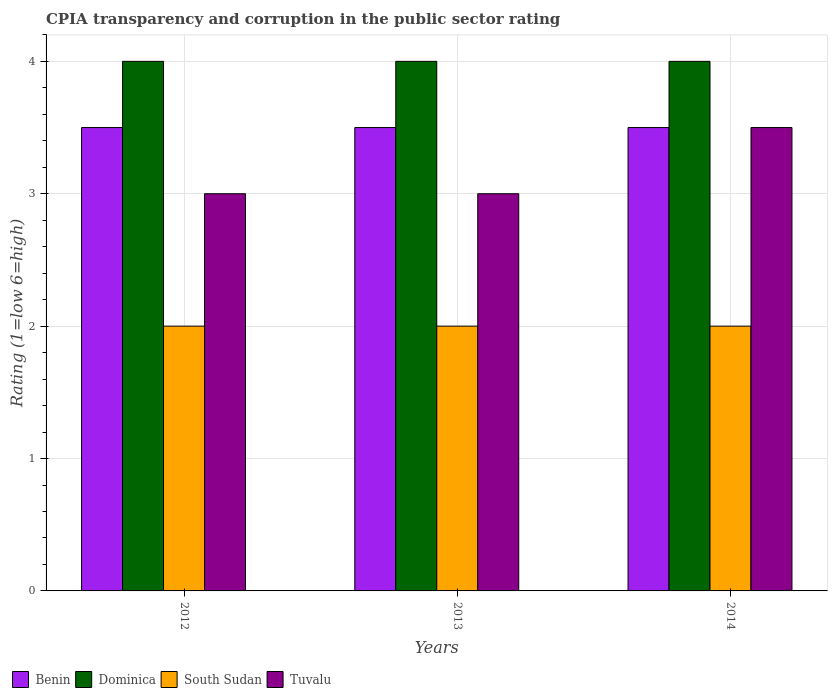How many different coloured bars are there?
Provide a short and direct response. 4. How many bars are there on the 1st tick from the left?
Your answer should be compact. 4. How many bars are there on the 3rd tick from the right?
Give a very brief answer. 4. In how many cases, is the number of bars for a given year not equal to the number of legend labels?
Keep it short and to the point. 0. In which year was the CPIA rating in Dominica minimum?
Offer a very short reply. 2012. In the year 2012, what is the difference between the CPIA rating in Tuvalu and CPIA rating in South Sudan?
Keep it short and to the point. 1. What is the ratio of the CPIA rating in South Sudan in 2012 to that in 2014?
Make the answer very short. 1. Is the difference between the CPIA rating in Tuvalu in 2013 and 2014 greater than the difference between the CPIA rating in South Sudan in 2013 and 2014?
Provide a succinct answer. No. In how many years, is the CPIA rating in South Sudan greater than the average CPIA rating in South Sudan taken over all years?
Ensure brevity in your answer.  0. What does the 1st bar from the left in 2013 represents?
Offer a terse response. Benin. What does the 2nd bar from the right in 2013 represents?
Ensure brevity in your answer.  South Sudan. Is it the case that in every year, the sum of the CPIA rating in Dominica and CPIA rating in Benin is greater than the CPIA rating in Tuvalu?
Keep it short and to the point. Yes. How many bars are there?
Offer a terse response. 12. Are all the bars in the graph horizontal?
Your answer should be very brief. No. What is the difference between two consecutive major ticks on the Y-axis?
Your response must be concise. 1. Are the values on the major ticks of Y-axis written in scientific E-notation?
Your response must be concise. No. Does the graph contain any zero values?
Your response must be concise. No. Where does the legend appear in the graph?
Your response must be concise. Bottom left. How many legend labels are there?
Keep it short and to the point. 4. What is the title of the graph?
Provide a short and direct response. CPIA transparency and corruption in the public sector rating. What is the label or title of the X-axis?
Provide a succinct answer. Years. What is the label or title of the Y-axis?
Your answer should be very brief. Rating (1=low 6=high). What is the Rating (1=low 6=high) of South Sudan in 2012?
Make the answer very short. 2. What is the Rating (1=low 6=high) of Dominica in 2014?
Your answer should be very brief. 4. Across all years, what is the maximum Rating (1=low 6=high) in Dominica?
Ensure brevity in your answer.  4. Across all years, what is the maximum Rating (1=low 6=high) of South Sudan?
Your answer should be very brief. 2. Across all years, what is the minimum Rating (1=low 6=high) in South Sudan?
Keep it short and to the point. 2. Across all years, what is the minimum Rating (1=low 6=high) in Tuvalu?
Your answer should be compact. 3. What is the total Rating (1=low 6=high) of Dominica in the graph?
Offer a terse response. 12. What is the difference between the Rating (1=low 6=high) in Benin in 2012 and that in 2013?
Your answer should be compact. 0. What is the difference between the Rating (1=low 6=high) in South Sudan in 2012 and that in 2013?
Your response must be concise. 0. What is the difference between the Rating (1=low 6=high) in Tuvalu in 2012 and that in 2013?
Your response must be concise. 0. What is the difference between the Rating (1=low 6=high) in Benin in 2013 and that in 2014?
Make the answer very short. 0. What is the difference between the Rating (1=low 6=high) in Tuvalu in 2013 and that in 2014?
Your answer should be very brief. -0.5. What is the difference between the Rating (1=low 6=high) of Benin in 2012 and the Rating (1=low 6=high) of South Sudan in 2013?
Your response must be concise. 1.5. What is the difference between the Rating (1=low 6=high) of Benin in 2012 and the Rating (1=low 6=high) of Tuvalu in 2013?
Your answer should be compact. 0.5. What is the difference between the Rating (1=low 6=high) in Dominica in 2012 and the Rating (1=low 6=high) in South Sudan in 2013?
Make the answer very short. 2. What is the difference between the Rating (1=low 6=high) of Dominica in 2012 and the Rating (1=low 6=high) of Tuvalu in 2013?
Keep it short and to the point. 1. What is the difference between the Rating (1=low 6=high) in South Sudan in 2012 and the Rating (1=low 6=high) in Tuvalu in 2013?
Provide a short and direct response. -1. What is the difference between the Rating (1=low 6=high) of Benin in 2012 and the Rating (1=low 6=high) of South Sudan in 2014?
Offer a very short reply. 1.5. What is the difference between the Rating (1=low 6=high) of Dominica in 2012 and the Rating (1=low 6=high) of Tuvalu in 2014?
Ensure brevity in your answer.  0.5. What is the difference between the Rating (1=low 6=high) in Benin in 2013 and the Rating (1=low 6=high) in Dominica in 2014?
Give a very brief answer. -0.5. What is the difference between the Rating (1=low 6=high) of Benin in 2013 and the Rating (1=low 6=high) of South Sudan in 2014?
Provide a succinct answer. 1.5. What is the difference between the Rating (1=low 6=high) in Dominica in 2013 and the Rating (1=low 6=high) in South Sudan in 2014?
Offer a terse response. 2. What is the difference between the Rating (1=low 6=high) of South Sudan in 2013 and the Rating (1=low 6=high) of Tuvalu in 2014?
Ensure brevity in your answer.  -1.5. What is the average Rating (1=low 6=high) in Benin per year?
Provide a short and direct response. 3.5. What is the average Rating (1=low 6=high) in Dominica per year?
Provide a short and direct response. 4. What is the average Rating (1=low 6=high) of South Sudan per year?
Your answer should be very brief. 2. What is the average Rating (1=low 6=high) of Tuvalu per year?
Your answer should be very brief. 3.17. In the year 2012, what is the difference between the Rating (1=low 6=high) of Dominica and Rating (1=low 6=high) of South Sudan?
Give a very brief answer. 2. In the year 2012, what is the difference between the Rating (1=low 6=high) of Dominica and Rating (1=low 6=high) of Tuvalu?
Your response must be concise. 1. In the year 2012, what is the difference between the Rating (1=low 6=high) of South Sudan and Rating (1=low 6=high) of Tuvalu?
Your answer should be very brief. -1. In the year 2013, what is the difference between the Rating (1=low 6=high) in Benin and Rating (1=low 6=high) in South Sudan?
Your answer should be compact. 1.5. In the year 2013, what is the difference between the Rating (1=low 6=high) of Benin and Rating (1=low 6=high) of Tuvalu?
Your answer should be very brief. 0.5. In the year 2013, what is the difference between the Rating (1=low 6=high) of South Sudan and Rating (1=low 6=high) of Tuvalu?
Your answer should be very brief. -1. In the year 2014, what is the difference between the Rating (1=low 6=high) in Benin and Rating (1=low 6=high) in Tuvalu?
Your answer should be compact. 0. In the year 2014, what is the difference between the Rating (1=low 6=high) of Dominica and Rating (1=low 6=high) of Tuvalu?
Your answer should be very brief. 0.5. What is the ratio of the Rating (1=low 6=high) of Benin in 2012 to that in 2013?
Keep it short and to the point. 1. What is the ratio of the Rating (1=low 6=high) in Dominica in 2012 to that in 2013?
Offer a very short reply. 1. What is the ratio of the Rating (1=low 6=high) of South Sudan in 2012 to that in 2013?
Your answer should be very brief. 1. What is the ratio of the Rating (1=low 6=high) of Tuvalu in 2012 to that in 2013?
Offer a very short reply. 1. What is the ratio of the Rating (1=low 6=high) in South Sudan in 2012 to that in 2014?
Provide a succinct answer. 1. What is the ratio of the Rating (1=low 6=high) in Benin in 2013 to that in 2014?
Keep it short and to the point. 1. What is the ratio of the Rating (1=low 6=high) of Dominica in 2013 to that in 2014?
Ensure brevity in your answer.  1. What is the difference between the highest and the second highest Rating (1=low 6=high) in Benin?
Provide a short and direct response. 0. What is the difference between the highest and the lowest Rating (1=low 6=high) in Benin?
Keep it short and to the point. 0. What is the difference between the highest and the lowest Rating (1=low 6=high) of Tuvalu?
Offer a very short reply. 0.5. 